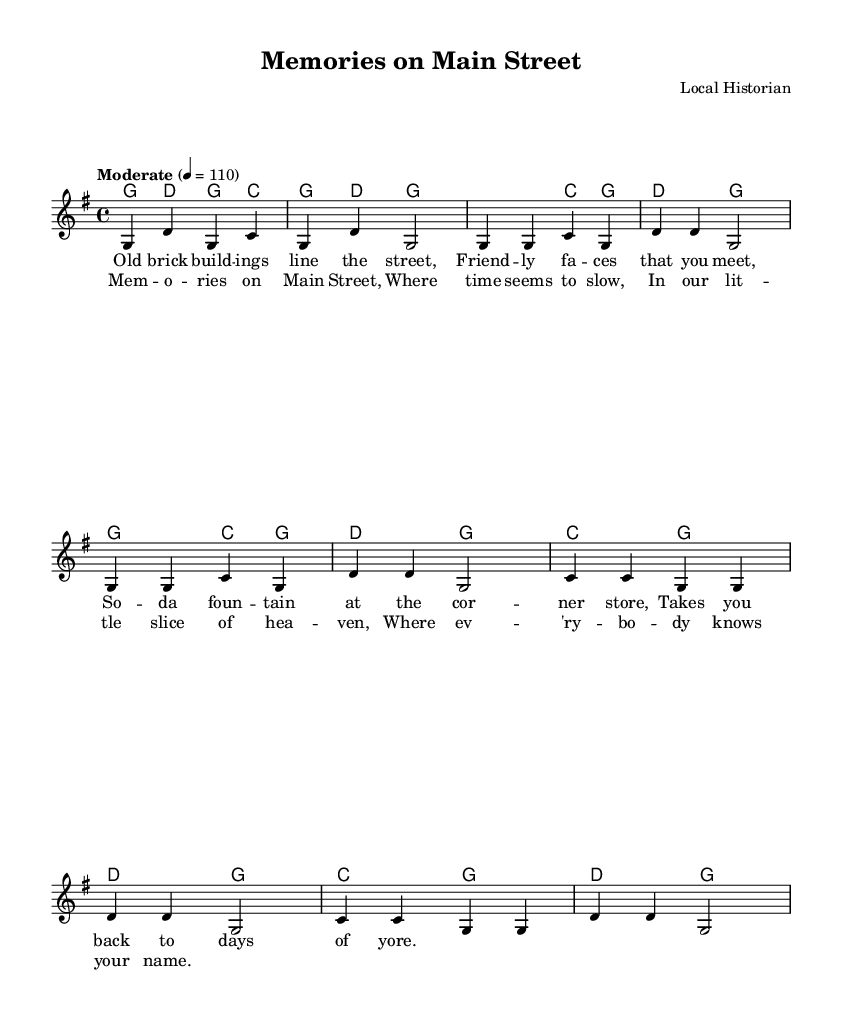What is the key signature of this music? The key signature is G major, which has one sharp.
Answer: G major What is the time signature of this music? The time signature is 4/4, indicating four beats per measure.
Answer: 4/4 What is the tempo marking of this piece? The tempo marking indicates a moderate pace at 110 beats per minute.
Answer: Moderate 110 How many measures are in the verse before the chorus? The verse consists of four measures before transitioning into the chorus.
Answer: Four measures What is the lyrical theme of the song? The lyrics celebrate a nostalgic view of small-town life, highlighting community and familiarity.
Answer: Nostalgia for small-town life Which chord is played on the first beat of the chorus? The first chord in the chorus is C major, marking the beginning of the section.
Answer: C major How do the verses and chorus differ in their musical structure? The verses have a repeating melodic line that is more intimate, while the chorus introduces a stronger, more uplifting harmony.
Answer: Verses are intimate; choruses are uplifting 